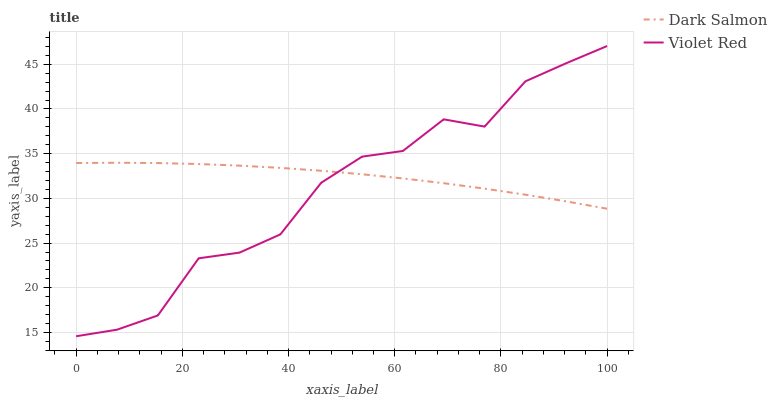Does Violet Red have the minimum area under the curve?
Answer yes or no. Yes. Does Dark Salmon have the maximum area under the curve?
Answer yes or no. Yes. Does Dark Salmon have the minimum area under the curve?
Answer yes or no. No. Is Dark Salmon the smoothest?
Answer yes or no. Yes. Is Violet Red the roughest?
Answer yes or no. Yes. Is Dark Salmon the roughest?
Answer yes or no. No. Does Violet Red have the lowest value?
Answer yes or no. Yes. Does Dark Salmon have the lowest value?
Answer yes or no. No. Does Violet Red have the highest value?
Answer yes or no. Yes. Does Dark Salmon have the highest value?
Answer yes or no. No. Does Dark Salmon intersect Violet Red?
Answer yes or no. Yes. Is Dark Salmon less than Violet Red?
Answer yes or no. No. Is Dark Salmon greater than Violet Red?
Answer yes or no. No. 